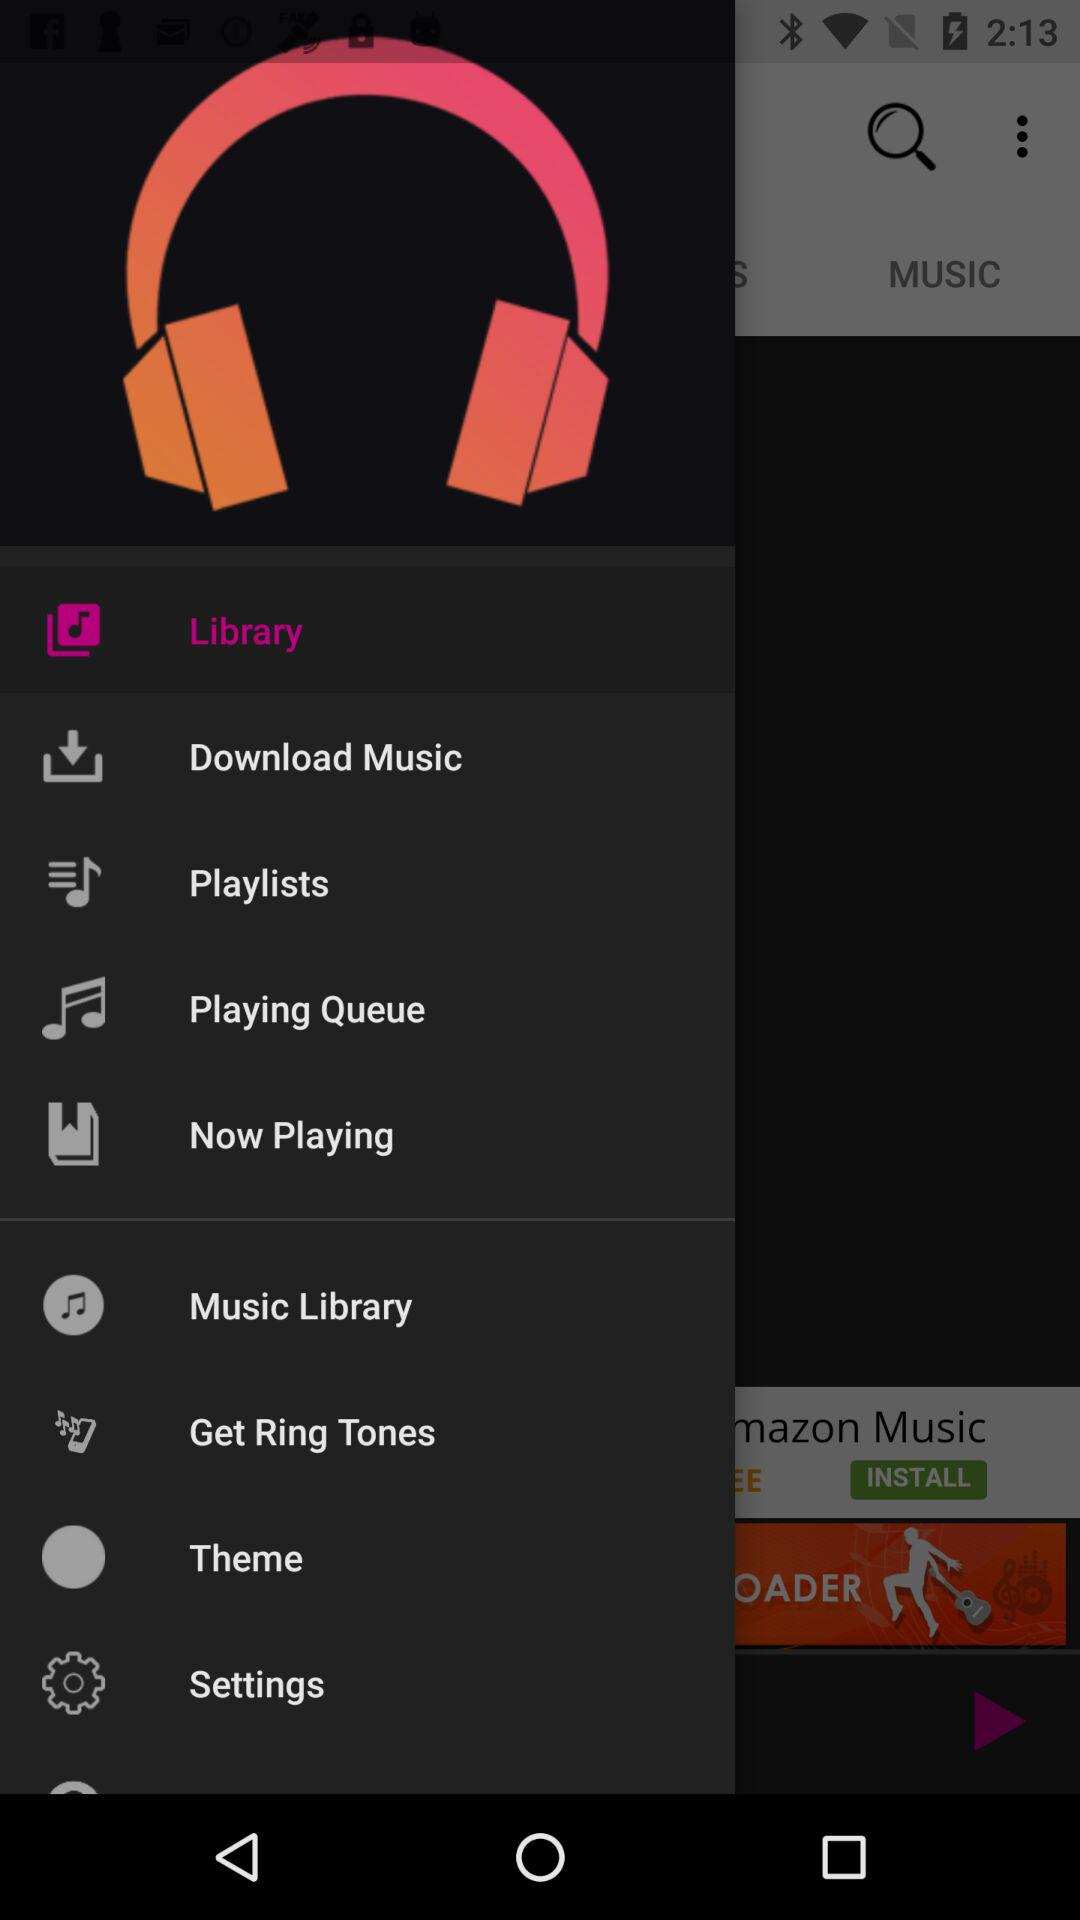What tab am I on? The tab is "ALBUMS". 